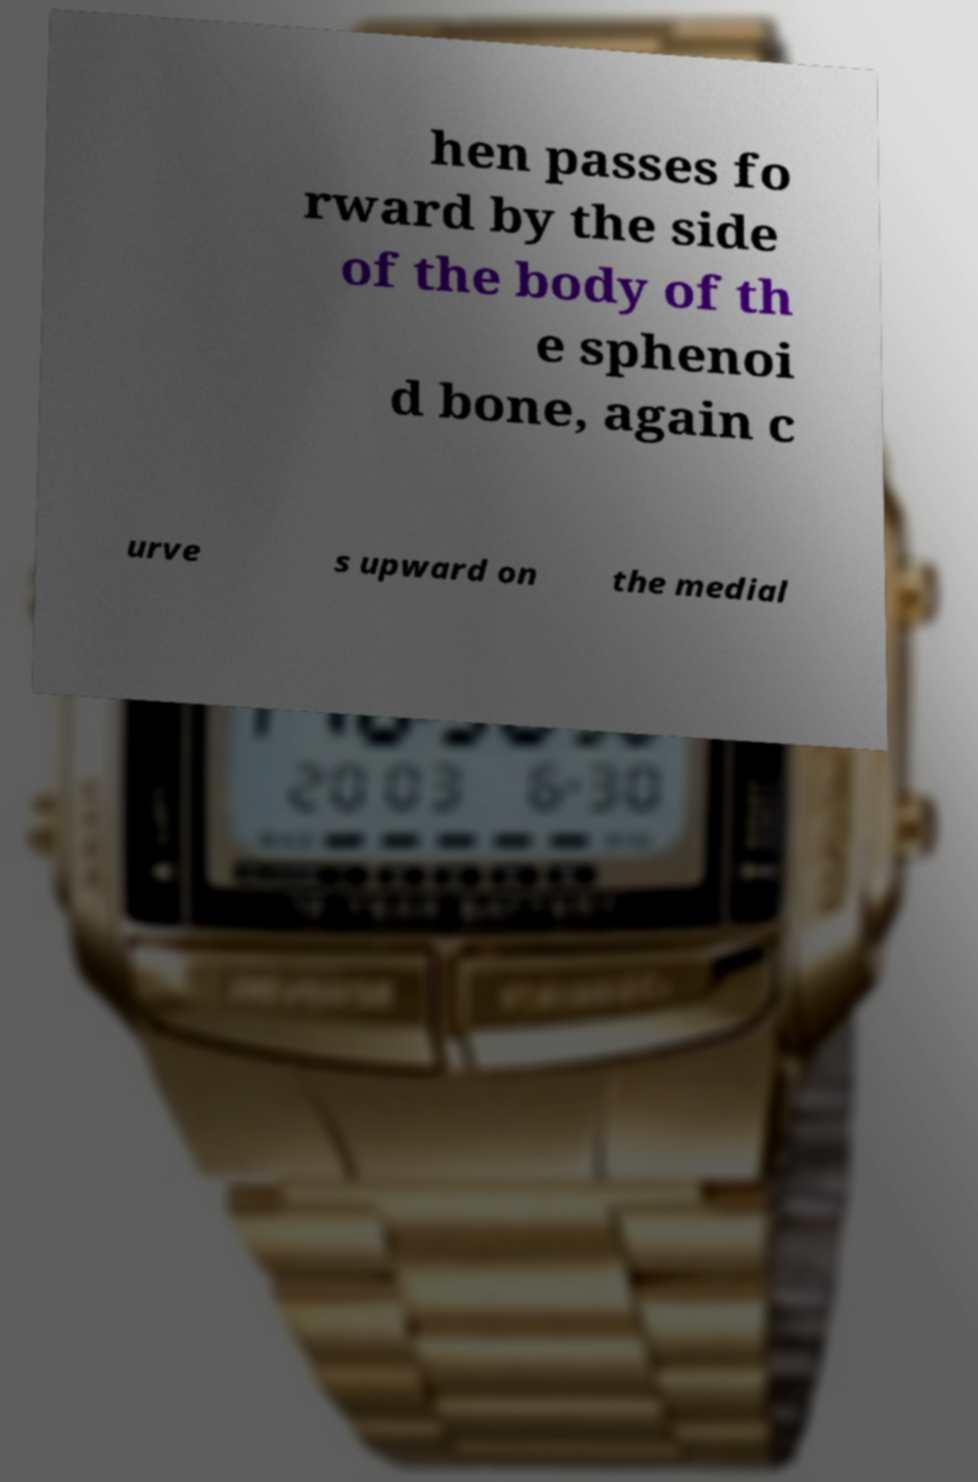I need the written content from this picture converted into text. Can you do that? hen passes fo rward by the side of the body of th e sphenoi d bone, again c urve s upward on the medial 